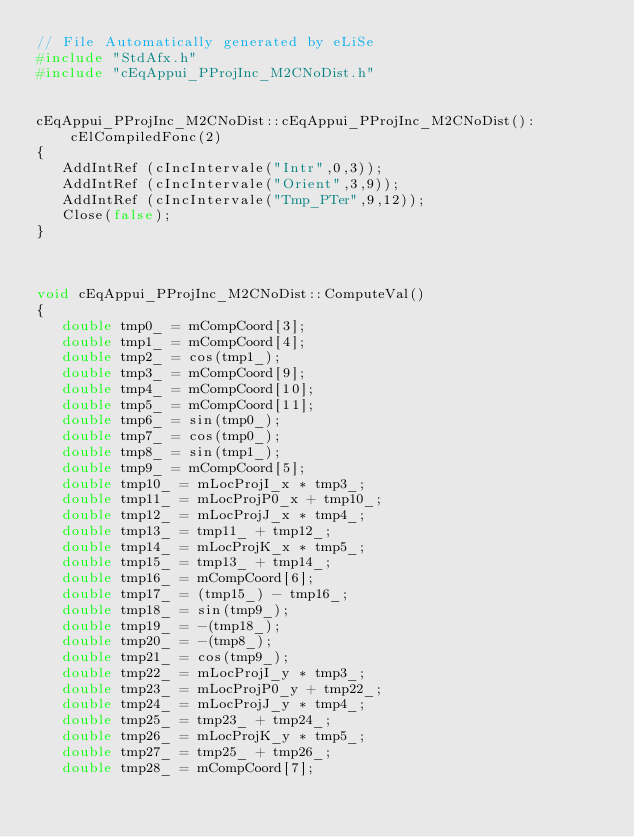<code> <loc_0><loc_0><loc_500><loc_500><_C++_>// File Automatically generated by eLiSe
#include "StdAfx.h"
#include "cEqAppui_PProjInc_M2CNoDist.h"


cEqAppui_PProjInc_M2CNoDist::cEqAppui_PProjInc_M2CNoDist():
    cElCompiledFonc(2)
{
   AddIntRef (cIncIntervale("Intr",0,3));
   AddIntRef (cIncIntervale("Orient",3,9));
   AddIntRef (cIncIntervale("Tmp_PTer",9,12));
   Close(false);
}



void cEqAppui_PProjInc_M2CNoDist::ComputeVal()
{
   double tmp0_ = mCompCoord[3];
   double tmp1_ = mCompCoord[4];
   double tmp2_ = cos(tmp1_);
   double tmp3_ = mCompCoord[9];
   double tmp4_ = mCompCoord[10];
   double tmp5_ = mCompCoord[11];
   double tmp6_ = sin(tmp0_);
   double tmp7_ = cos(tmp0_);
   double tmp8_ = sin(tmp1_);
   double tmp9_ = mCompCoord[5];
   double tmp10_ = mLocProjI_x * tmp3_;
   double tmp11_ = mLocProjP0_x + tmp10_;
   double tmp12_ = mLocProjJ_x * tmp4_;
   double tmp13_ = tmp11_ + tmp12_;
   double tmp14_ = mLocProjK_x * tmp5_;
   double tmp15_ = tmp13_ + tmp14_;
   double tmp16_ = mCompCoord[6];
   double tmp17_ = (tmp15_) - tmp16_;
   double tmp18_ = sin(tmp9_);
   double tmp19_ = -(tmp18_);
   double tmp20_ = -(tmp8_);
   double tmp21_ = cos(tmp9_);
   double tmp22_ = mLocProjI_y * tmp3_;
   double tmp23_ = mLocProjP0_y + tmp22_;
   double tmp24_ = mLocProjJ_y * tmp4_;
   double tmp25_ = tmp23_ + tmp24_;
   double tmp26_ = mLocProjK_y * tmp5_;
   double tmp27_ = tmp25_ + tmp26_;
   double tmp28_ = mCompCoord[7];</code> 